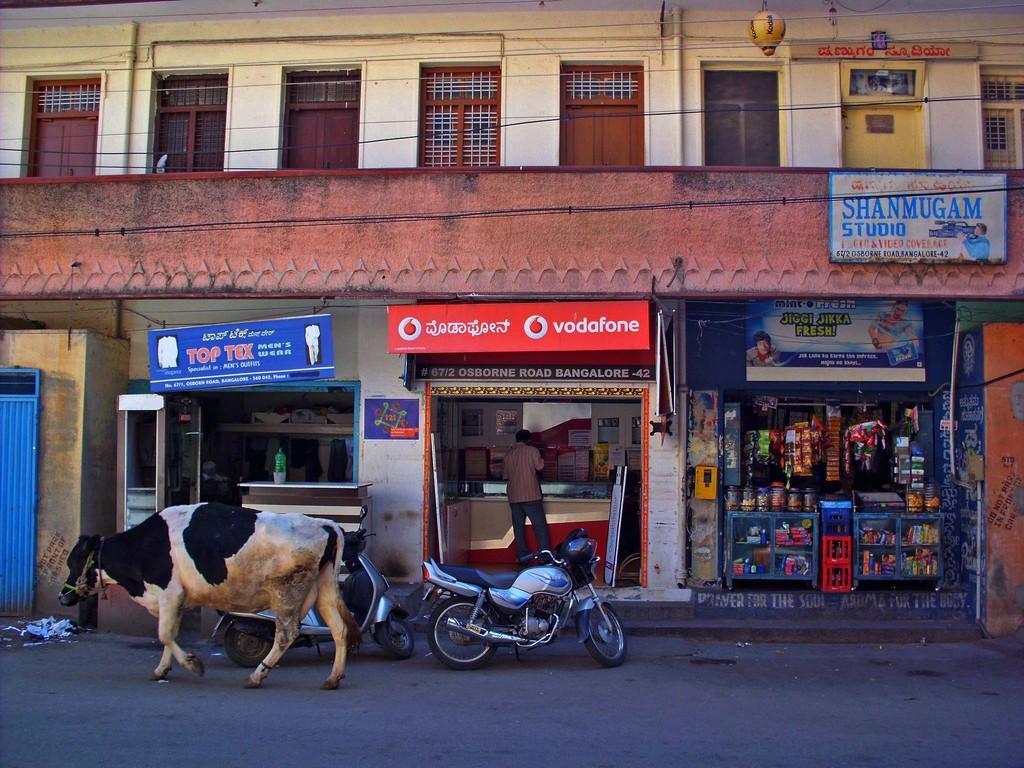How would you summarize this image in a sentence or two? In this image I can see few stalls. In front I can see an animal in black and white color and I can also see few vehicles. Background the building is in cream and brown color and I can also see few doors in brown color. 